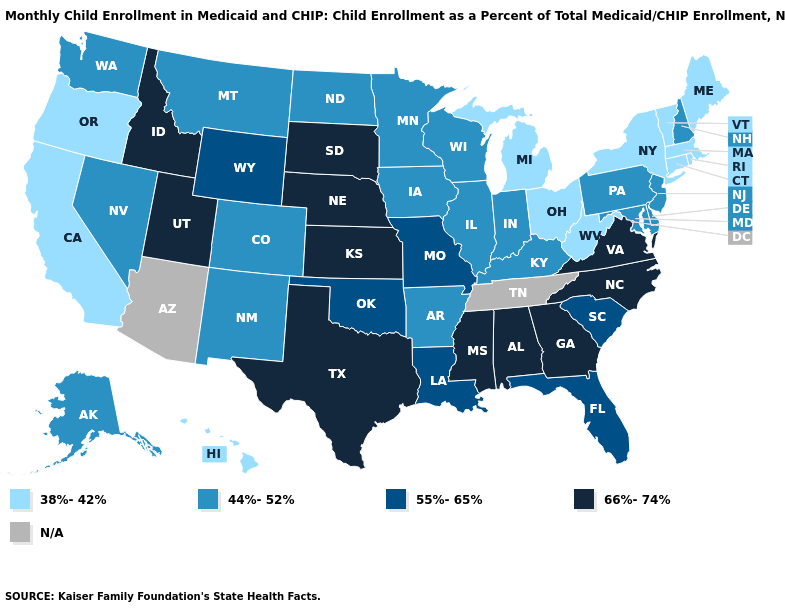Name the states that have a value in the range 38%-42%?
Give a very brief answer. California, Connecticut, Hawaii, Maine, Massachusetts, Michigan, New York, Ohio, Oregon, Rhode Island, Vermont, West Virginia. What is the value of Florida?
Quick response, please. 55%-65%. What is the highest value in the USA?
Short answer required. 66%-74%. What is the value of Kentucky?
Be succinct. 44%-52%. Name the states that have a value in the range 44%-52%?
Short answer required. Alaska, Arkansas, Colorado, Delaware, Illinois, Indiana, Iowa, Kentucky, Maryland, Minnesota, Montana, Nevada, New Hampshire, New Jersey, New Mexico, North Dakota, Pennsylvania, Washington, Wisconsin. Does the map have missing data?
Answer briefly. Yes. Does Pennsylvania have the lowest value in the USA?
Short answer required. No. Name the states that have a value in the range N/A?
Short answer required. Arizona, Tennessee. Name the states that have a value in the range 44%-52%?
Be succinct. Alaska, Arkansas, Colorado, Delaware, Illinois, Indiana, Iowa, Kentucky, Maryland, Minnesota, Montana, Nevada, New Hampshire, New Jersey, New Mexico, North Dakota, Pennsylvania, Washington, Wisconsin. Which states hav the highest value in the West?
Give a very brief answer. Idaho, Utah. Which states hav the highest value in the South?
Short answer required. Alabama, Georgia, Mississippi, North Carolina, Texas, Virginia. Among the states that border Wyoming , which have the lowest value?
Concise answer only. Colorado, Montana. Among the states that border Montana , does North Dakota have the highest value?
Write a very short answer. No. Does North Dakota have the highest value in the MidWest?
Answer briefly. No. Is the legend a continuous bar?
Keep it brief. No. 